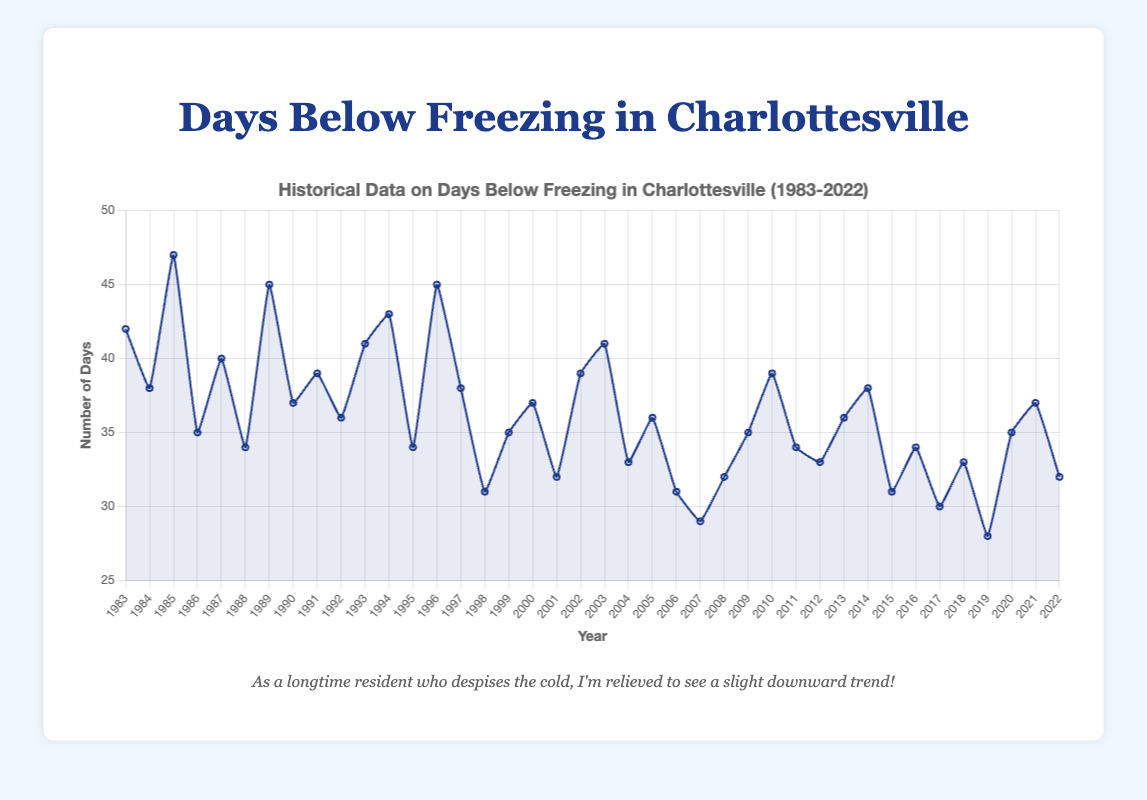Which winter season had the most days below freezing? The winter season with the most days below freezing corresponds to the highest point on the plot. Upon examining the highest peaks, the winter season of 1985 with 47 days below freezing stands out.
Answer: 1985 Which winter season had the least days below freezing? The winter season with the least days below freezing corresponds to the lowest point on the plot. The lowest value is seen in 2019 with 28 days below freezing.
Answer: 2019 What is the average number of days below freezing per year? To find the average, sum all days below freezing from 1983 to 2022 and divide by the number of years. Sum = 42 + 38 + 47 + 35 + 40 + 34 + 45 + 37 + 39 + 36 + 41 + 43 + 34 + 45 + 38 + 31 + 35 + 37 + 32 + 39 + 41 + 33 + 36 + 31 + 29 + 32 + 35 + 39 + 34 + 33 + 36 + 38 + 31 + 34 + 30 + 33 + 28 + 35 + 37 + 32 = 1415. Number of years = 40. Average = 1415/40 = 35.375.
Answer: 35.375 How many times did Charlottesville have more than 40 days below freezing in a winter season? By counting the instances where the value exceeds 40 on the y-axis, we observe the following years: 1983, 1985, 1987, 1989, 1993, 1994, 1996, 2003. That totals 8 instances.
Answer: 8 Which year saw a sudden drop in the number of days below freezing from the previous year? Look for the largest negative change between any two consecutive years. From 1996 (45 days) to 1997 (38 days), there's a drop of 7 days. This is the largest noticeable sudden drop in the number of days below freezing.
Answer: 1997 What is the trend in the number of days below freezing over the 40-year period? The trend can be observed by looking at the pattern of the line curve over the years. Overall, despite fluctuations, there's a slight downward trend noticeable towards fewer days below freezing.
Answer: Downward trend Which two consecutive years had the largest total number of days below freezing combined? Add the number of days below freezing for consecutive years and compare. The combination yielding the highest sum is between 1985 (47 days) and 1986 (35 days), sum: 47 + 35 = 82 days.
Answer: 1985 and 1986 During which decade did Charlottesville experience the coldest winters on average based on the number of days below freezing? Calculate the average days below freezing per decade. 1980s: (42 + 38 + 47 + 35 + 40 + 34 + 45) / 10 ≈ 39. 1990s: (37 + 39 + 36 + 41 + 43 + 34 + 45 + 38 + 31 + 35) / 10 ≈ 37. 2000s: (37 + 32 + 39 + 41 + 33 + 36 + 31 + 29 + 32 + 35) / 10 ≈ 34.5. 2010s: (39 + 34 + 33 + 36 + 38 + 31 + 34 + 30 + 33 + 28) / 10 ≈ 33.6. The 1980s had the highest average of approximately 39 days.
Answer: 1980s 